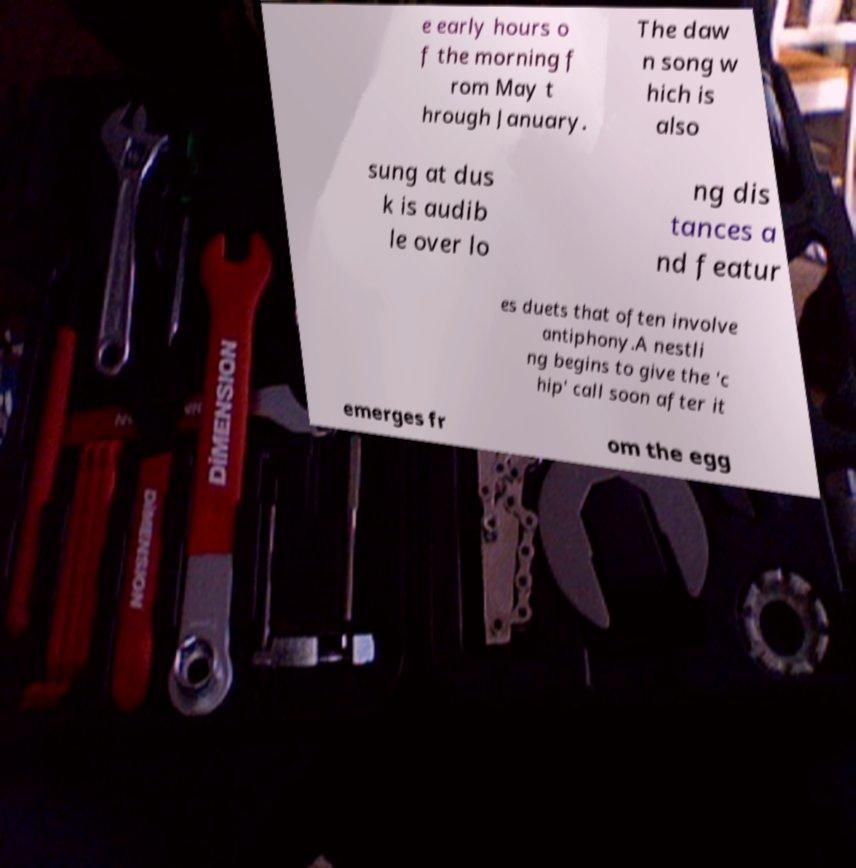Please identify and transcribe the text found in this image. e early hours o f the morning f rom May t hrough January. The daw n song w hich is also sung at dus k is audib le over lo ng dis tances a nd featur es duets that often involve antiphony.A nestli ng begins to give the 'c hip' call soon after it emerges fr om the egg 